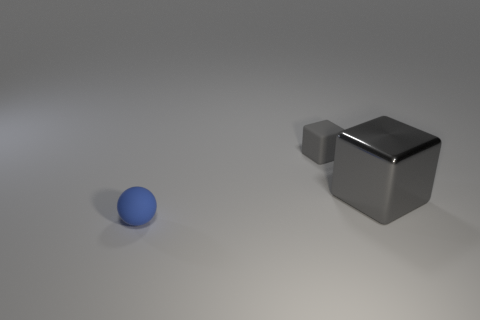Add 2 small blue matte spheres. How many objects exist? 5 Subtract all blocks. How many objects are left? 1 Subtract all gray rubber cylinders. Subtract all shiny objects. How many objects are left? 2 Add 2 matte blocks. How many matte blocks are left? 3 Add 3 blue objects. How many blue objects exist? 4 Subtract 0 brown cubes. How many objects are left? 3 